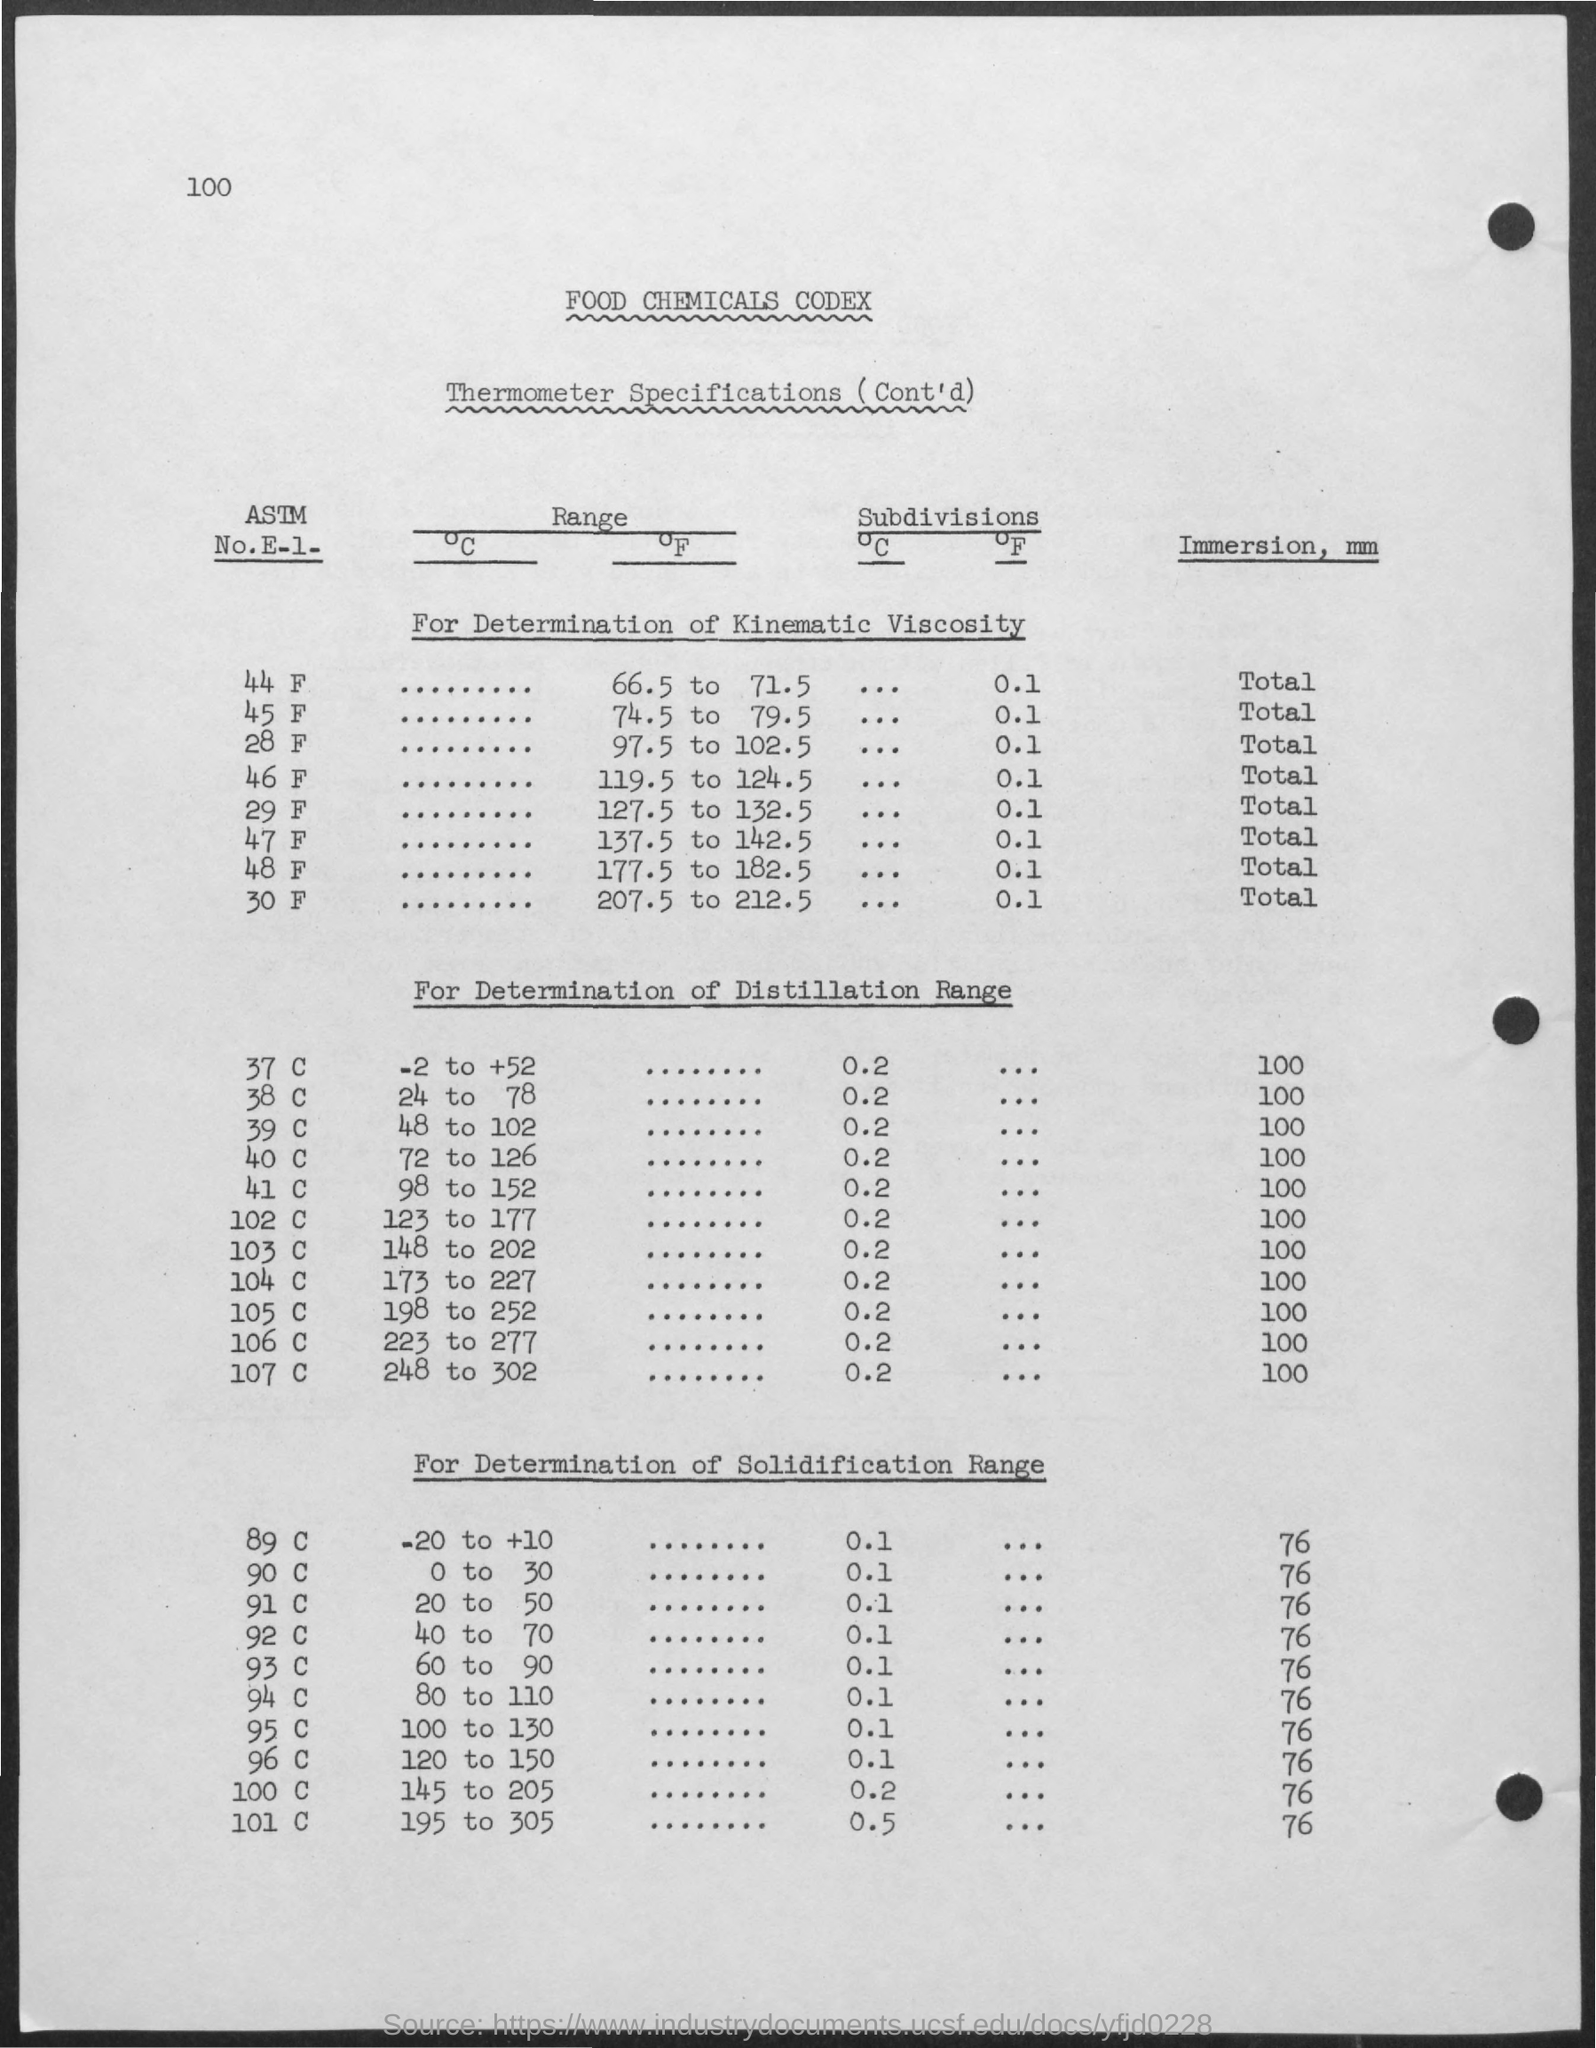In what unit,does immersion is measured?
Provide a short and direct response. Mm. What is the subdivisions of 44 F ?
Give a very brief answer. 0.1. What is the Range of 45 F ?
Offer a very short reply. 74.5 to 79.5. What is the Range for 37 C?
Your answer should be very brief. -2 to +52. What is immersion for 37 C in mm?
Your response must be concise. 100. 